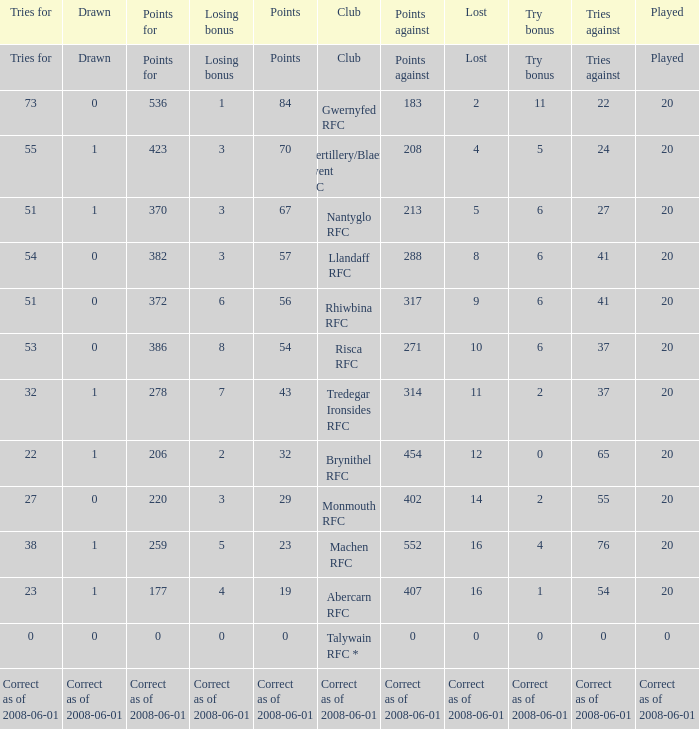If the points were 0, what was the losing bonus? 0.0. Can you give me this table as a dict? {'header': ['Tries for', 'Drawn', 'Points for', 'Losing bonus', 'Points', 'Club', 'Points against', 'Lost', 'Try bonus', 'Tries against', 'Played'], 'rows': [['Tries for', 'Drawn', 'Points for', 'Losing bonus', 'Points', 'Club', 'Points against', 'Lost', 'Try bonus', 'Tries against', 'Played'], ['73', '0', '536', '1', '84', 'Gwernyfed RFC', '183', '2', '11', '22', '20'], ['55', '1', '423', '3', '70', 'Abertillery/Blaenau Gwent RFC', '208', '4', '5', '24', '20'], ['51', '1', '370', '3', '67', 'Nantyglo RFC', '213', '5', '6', '27', '20'], ['54', '0', '382', '3', '57', 'Llandaff RFC', '288', '8', '6', '41', '20'], ['51', '0', '372', '6', '56', 'Rhiwbina RFC', '317', '9', '6', '41', '20'], ['53', '0', '386', '8', '54', 'Risca RFC', '271', '10', '6', '37', '20'], ['32', '1', '278', '7', '43', 'Tredegar Ironsides RFC', '314', '11', '2', '37', '20'], ['22', '1', '206', '2', '32', 'Brynithel RFC', '454', '12', '0', '65', '20'], ['27', '0', '220', '3', '29', 'Monmouth RFC', '402', '14', '2', '55', '20'], ['38', '1', '259', '5', '23', 'Machen RFC', '552', '16', '4', '76', '20'], ['23', '1', '177', '4', '19', 'Abercarn RFC', '407', '16', '1', '54', '20'], ['0', '0', '0', '0', '0', 'Talywain RFC *', '0', '0', '0', '0', '0'], ['Correct as of 2008-06-01', 'Correct as of 2008-06-01', 'Correct as of 2008-06-01', 'Correct as of 2008-06-01', 'Correct as of 2008-06-01', 'Correct as of 2008-06-01', 'Correct as of 2008-06-01', 'Correct as of 2008-06-01', 'Correct as of 2008-06-01', 'Correct as of 2008-06-01', 'Correct as of 2008-06-01']]} 